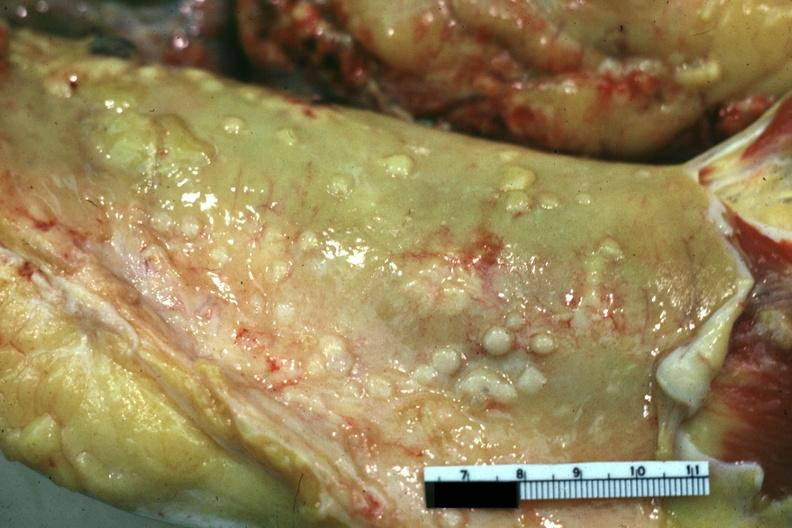s abdomen present?
Answer the question using a single word or phrase. Yes 